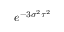<formula> <loc_0><loc_0><loc_500><loc_500>e ^ { - 3 \sigma ^ { 2 } \tau ^ { 2 } }</formula> 